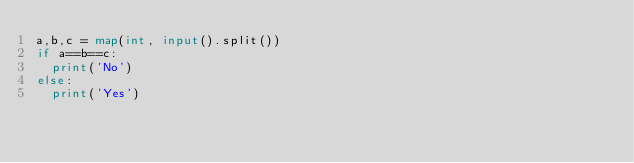Convert code to text. <code><loc_0><loc_0><loc_500><loc_500><_Python_>a,b,c = map(int, input().split())
if a==b==c:
  print('No')
else:
  print('Yes')</code> 